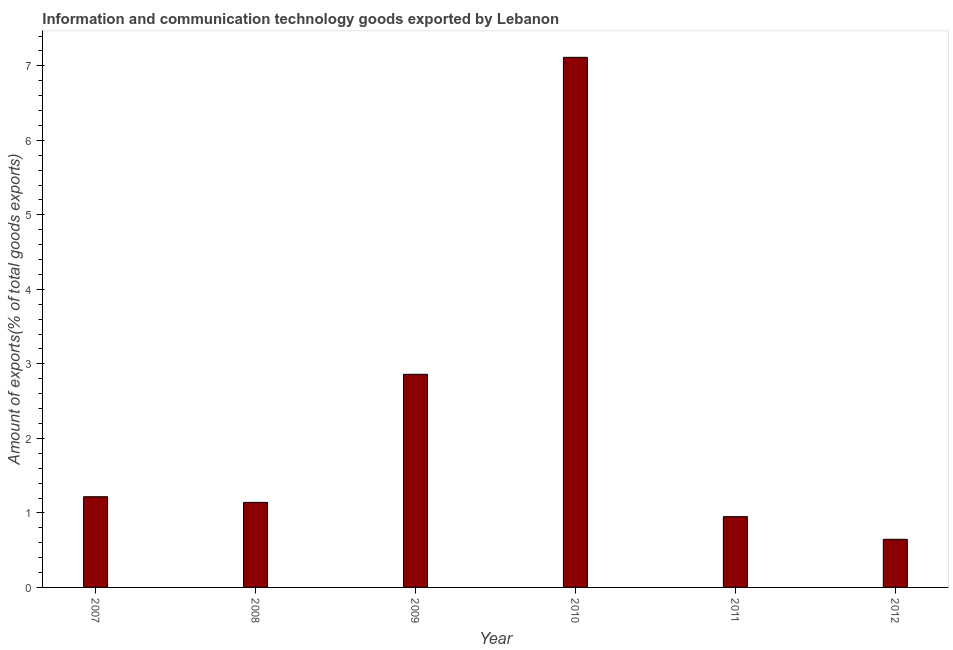Does the graph contain grids?
Provide a succinct answer. No. What is the title of the graph?
Your response must be concise. Information and communication technology goods exported by Lebanon. What is the label or title of the Y-axis?
Provide a succinct answer. Amount of exports(% of total goods exports). What is the amount of ict goods exports in 2010?
Make the answer very short. 7.11. Across all years, what is the maximum amount of ict goods exports?
Ensure brevity in your answer.  7.11. Across all years, what is the minimum amount of ict goods exports?
Provide a short and direct response. 0.65. What is the sum of the amount of ict goods exports?
Offer a very short reply. 13.93. What is the difference between the amount of ict goods exports in 2007 and 2008?
Make the answer very short. 0.08. What is the average amount of ict goods exports per year?
Keep it short and to the point. 2.32. What is the median amount of ict goods exports?
Ensure brevity in your answer.  1.18. Do a majority of the years between 2007 and 2012 (inclusive) have amount of ict goods exports greater than 4.4 %?
Your answer should be very brief. No. What is the ratio of the amount of ict goods exports in 2010 to that in 2011?
Your answer should be compact. 7.49. Is the amount of ict goods exports in 2010 less than that in 2011?
Make the answer very short. No. Is the difference between the amount of ict goods exports in 2008 and 2009 greater than the difference between any two years?
Give a very brief answer. No. What is the difference between the highest and the second highest amount of ict goods exports?
Provide a succinct answer. 4.25. What is the difference between the highest and the lowest amount of ict goods exports?
Your response must be concise. 6.47. How many bars are there?
Your answer should be compact. 6. Are all the bars in the graph horizontal?
Ensure brevity in your answer.  No. What is the Amount of exports(% of total goods exports) in 2007?
Offer a terse response. 1.22. What is the Amount of exports(% of total goods exports) of 2008?
Provide a succinct answer. 1.14. What is the Amount of exports(% of total goods exports) in 2009?
Your answer should be compact. 2.86. What is the Amount of exports(% of total goods exports) in 2010?
Provide a succinct answer. 7.11. What is the Amount of exports(% of total goods exports) in 2011?
Make the answer very short. 0.95. What is the Amount of exports(% of total goods exports) of 2012?
Give a very brief answer. 0.65. What is the difference between the Amount of exports(% of total goods exports) in 2007 and 2008?
Provide a short and direct response. 0.08. What is the difference between the Amount of exports(% of total goods exports) in 2007 and 2009?
Provide a short and direct response. -1.64. What is the difference between the Amount of exports(% of total goods exports) in 2007 and 2010?
Your answer should be compact. -5.9. What is the difference between the Amount of exports(% of total goods exports) in 2007 and 2011?
Give a very brief answer. 0.27. What is the difference between the Amount of exports(% of total goods exports) in 2007 and 2012?
Make the answer very short. 0.57. What is the difference between the Amount of exports(% of total goods exports) in 2008 and 2009?
Your answer should be compact. -1.72. What is the difference between the Amount of exports(% of total goods exports) in 2008 and 2010?
Keep it short and to the point. -5.97. What is the difference between the Amount of exports(% of total goods exports) in 2008 and 2011?
Give a very brief answer. 0.19. What is the difference between the Amount of exports(% of total goods exports) in 2008 and 2012?
Your answer should be compact. 0.5. What is the difference between the Amount of exports(% of total goods exports) in 2009 and 2010?
Offer a terse response. -4.25. What is the difference between the Amount of exports(% of total goods exports) in 2009 and 2011?
Provide a succinct answer. 1.91. What is the difference between the Amount of exports(% of total goods exports) in 2009 and 2012?
Keep it short and to the point. 2.21. What is the difference between the Amount of exports(% of total goods exports) in 2010 and 2011?
Provide a short and direct response. 6.16. What is the difference between the Amount of exports(% of total goods exports) in 2010 and 2012?
Keep it short and to the point. 6.47. What is the difference between the Amount of exports(% of total goods exports) in 2011 and 2012?
Provide a short and direct response. 0.3. What is the ratio of the Amount of exports(% of total goods exports) in 2007 to that in 2008?
Provide a short and direct response. 1.07. What is the ratio of the Amount of exports(% of total goods exports) in 2007 to that in 2009?
Keep it short and to the point. 0.43. What is the ratio of the Amount of exports(% of total goods exports) in 2007 to that in 2010?
Give a very brief answer. 0.17. What is the ratio of the Amount of exports(% of total goods exports) in 2007 to that in 2011?
Your answer should be compact. 1.28. What is the ratio of the Amount of exports(% of total goods exports) in 2007 to that in 2012?
Give a very brief answer. 1.89. What is the ratio of the Amount of exports(% of total goods exports) in 2008 to that in 2009?
Give a very brief answer. 0.4. What is the ratio of the Amount of exports(% of total goods exports) in 2008 to that in 2010?
Your answer should be very brief. 0.16. What is the ratio of the Amount of exports(% of total goods exports) in 2008 to that in 2011?
Offer a terse response. 1.2. What is the ratio of the Amount of exports(% of total goods exports) in 2008 to that in 2012?
Provide a short and direct response. 1.77. What is the ratio of the Amount of exports(% of total goods exports) in 2009 to that in 2010?
Make the answer very short. 0.4. What is the ratio of the Amount of exports(% of total goods exports) in 2009 to that in 2011?
Provide a short and direct response. 3.01. What is the ratio of the Amount of exports(% of total goods exports) in 2009 to that in 2012?
Provide a short and direct response. 4.43. What is the ratio of the Amount of exports(% of total goods exports) in 2010 to that in 2011?
Your response must be concise. 7.49. What is the ratio of the Amount of exports(% of total goods exports) in 2010 to that in 2012?
Ensure brevity in your answer.  11.02. What is the ratio of the Amount of exports(% of total goods exports) in 2011 to that in 2012?
Your response must be concise. 1.47. 